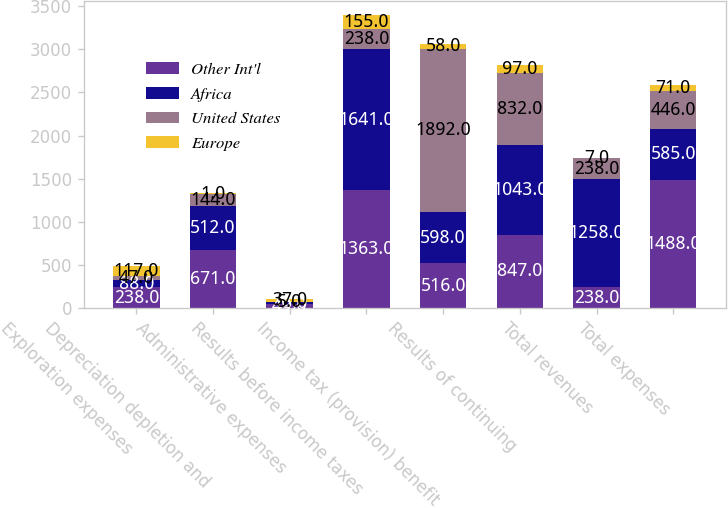Convert chart to OTSL. <chart><loc_0><loc_0><loc_500><loc_500><stacked_bar_chart><ecel><fcel>Exploration expenses<fcel>Depreciation depletion and<fcel>Administrative expenses<fcel>Results before income taxes<fcel>Income tax (provision) benefit<fcel>Results of continuing<fcel>Total revenues<fcel>Total expenses<nl><fcel>Other Int'l<fcel>238<fcel>671<fcel>49<fcel>1363<fcel>516<fcel>847<fcel>238<fcel>1488<nl><fcel>Africa<fcel>88<fcel>512<fcel>15<fcel>1641<fcel>598<fcel>1043<fcel>1258<fcel>585<nl><fcel>United States<fcel>47<fcel>144<fcel>5<fcel>238<fcel>1892<fcel>832<fcel>238<fcel>446<nl><fcel>Europe<fcel>117<fcel>1<fcel>37<fcel>155<fcel>58<fcel>97<fcel>7<fcel>71<nl></chart> 